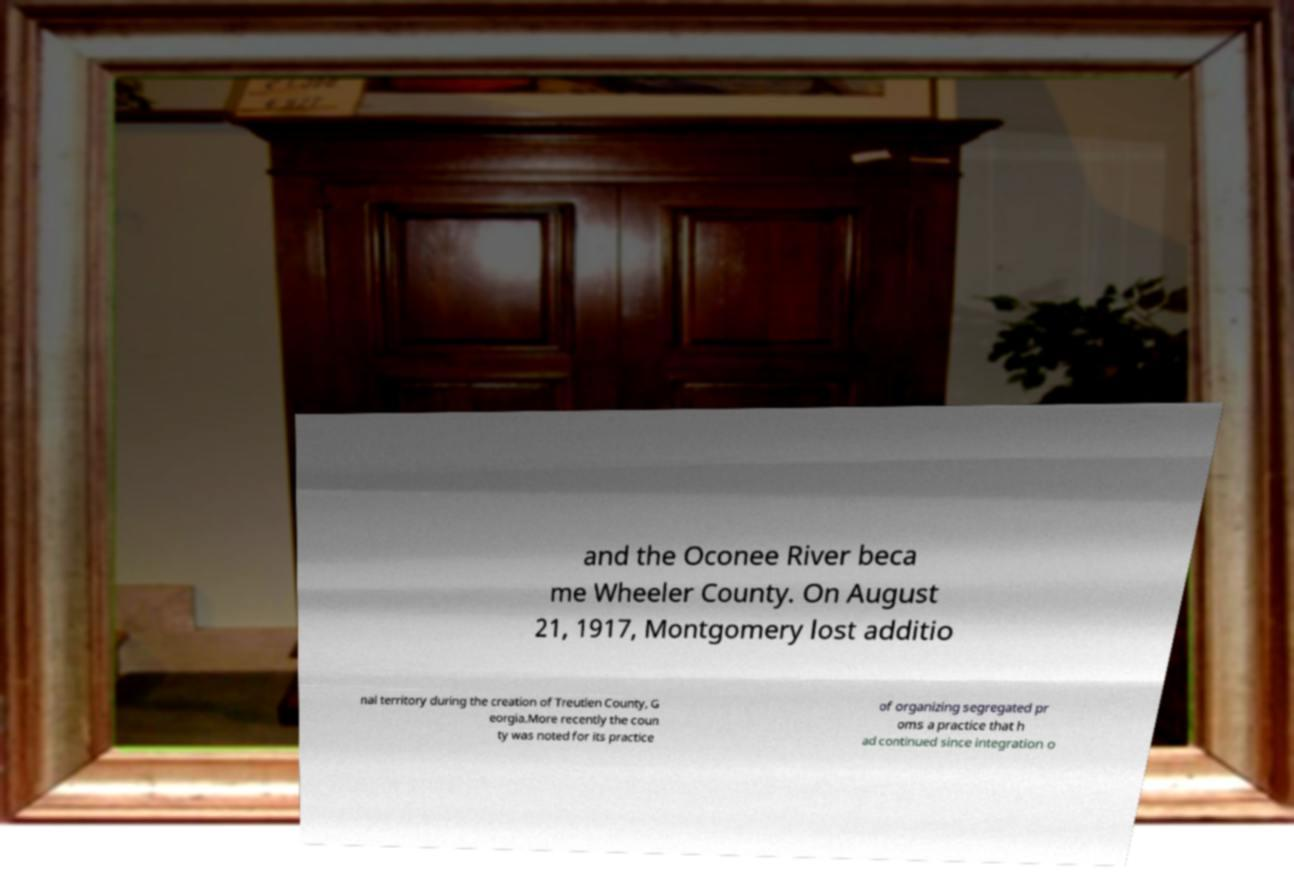What messages or text are displayed in this image? I need them in a readable, typed format. and the Oconee River beca me Wheeler County. On August 21, 1917, Montgomery lost additio nal territory during the creation of Treutlen County, G eorgia.More recently the coun ty was noted for its practice of organizing segregated pr oms a practice that h ad continued since integration o 